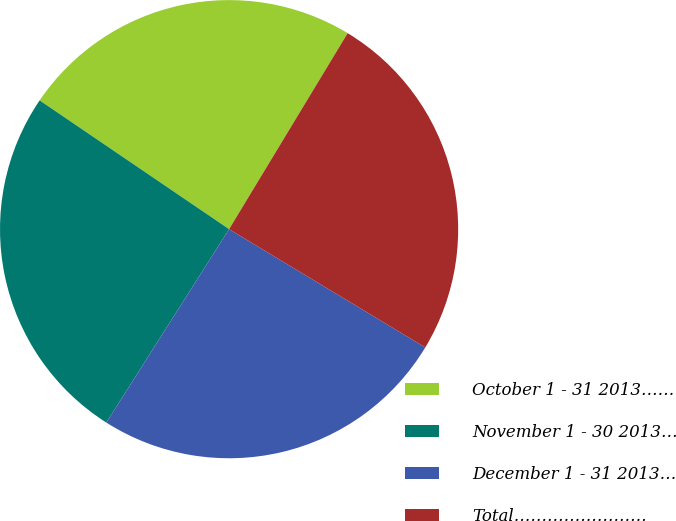Convert chart to OTSL. <chart><loc_0><loc_0><loc_500><loc_500><pie_chart><fcel>October 1 - 31 2013……<fcel>November 1 - 30 2013…<fcel>December 1 - 31 2013…<fcel>Total……………………<nl><fcel>24.16%<fcel>25.5%<fcel>25.37%<fcel>24.98%<nl></chart> 